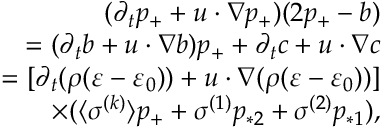Convert formula to latex. <formula><loc_0><loc_0><loc_500><loc_500>\begin{array} { r } { ( \partial _ { t } p _ { + } + u \cdot \nabla p _ { + } ) ( 2 p _ { + } - b ) } \\ { = ( \partial _ { t } b + u \cdot \nabla b ) p _ { + } + \partial _ { t } c + u \cdot \nabla c } \\ { = [ \partial _ { t } ( \rho ( \varepsilon - \varepsilon _ { 0 } ) ) + u \cdot \nabla ( \rho ( \varepsilon - \varepsilon _ { 0 } ) ) ] } \\ { \times ( \langle \sigma ^ { ( k ) } \rangle p _ { + } + \sigma ^ { ( 1 ) } p _ { * 2 } + \sigma ^ { ( 2 ) } p _ { * 1 } ) , } \end{array}</formula> 